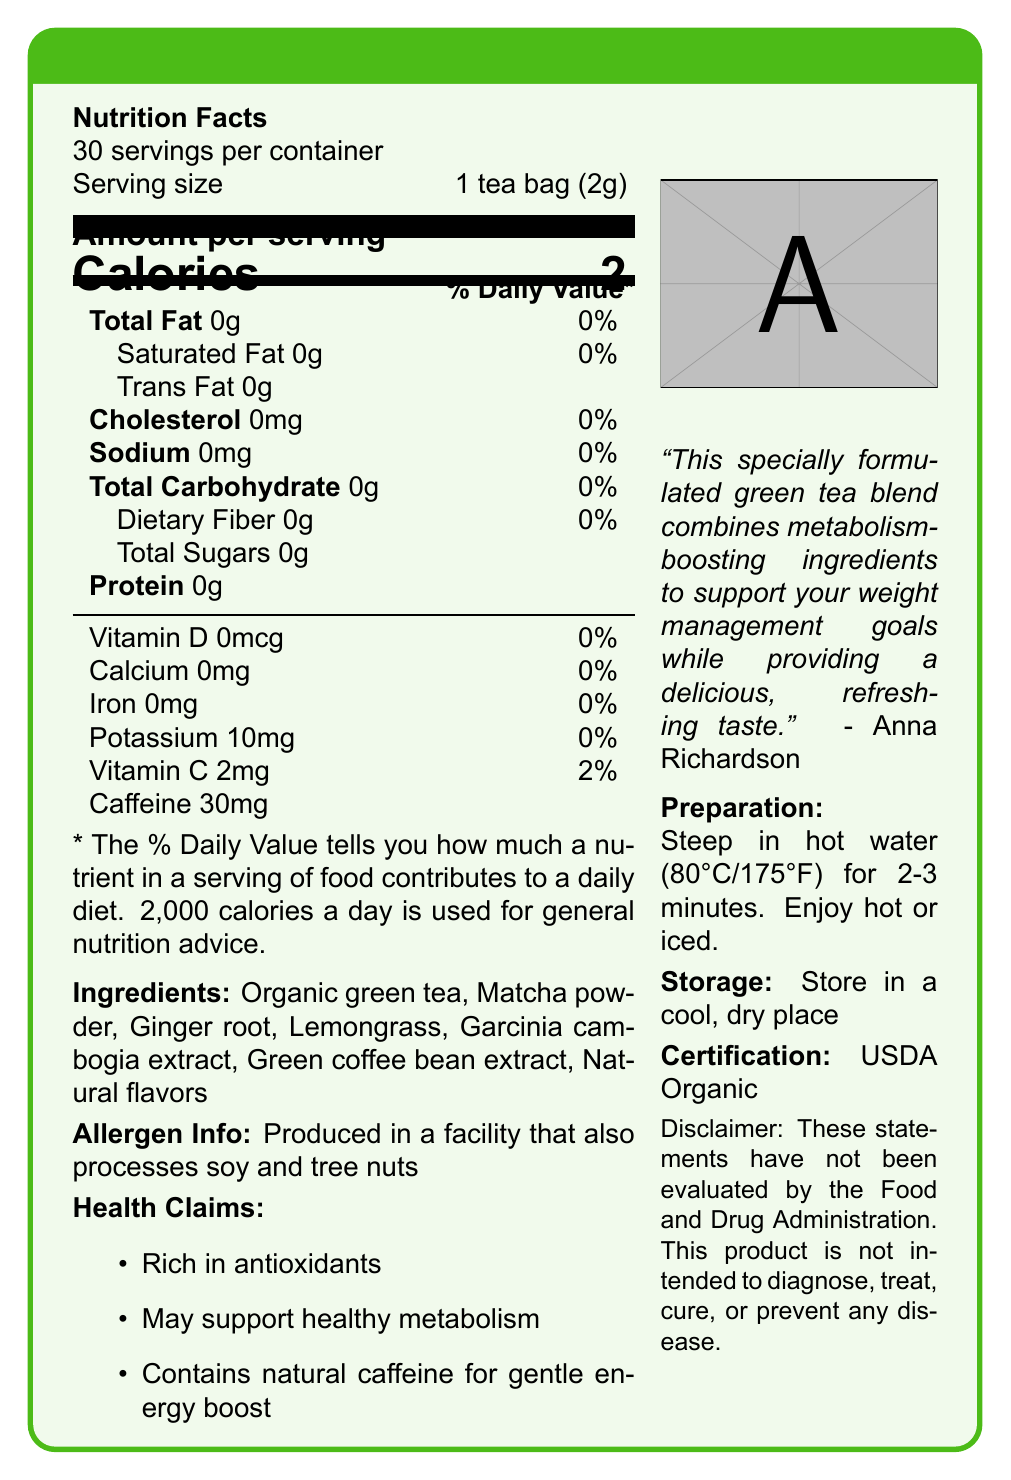what is the serving size? The serving size is clearly mentioned as "1 tea bag (2g)" in the document.
Answer: 1 tea bag (2g) how many calories are in one serving? The document lists the calories per serving as 2.
Answer: 2 what are the main ingredients in the tea blend? The main ingredients are listed under the "Ingredients" section.
Answer: Organic green tea, Matcha powder, Ginger root, Lemongrass, Garcinia cambogia extract, Green coffee bean extract, Natural flavors how many milligrams of caffeine does one serving contain? The caffeine content per serving is specified as 30 mg in the document.
Answer: 30 mg which vitamins are present in the tea blend? The document mentions Vitamin D (0 mcg) and Vitamin C (2 mg) in the nutrition facts.
Answer: Vitamin D, Vitamin C what are some of the health claims associated with the tea blend? A. Boosts energy B. Supports eye health C. Rich in antioxidants D. Supports healthy metabolism The health claims listed are "Rich in antioxidants" and "May support healthy metabolism".
Answer: C, D what allergen information is provided? The allergen information is clearly stated as "Produced in a facility that also processes soy and tree nuts".
Answer: Produced in a facility that also processes soy and tree nuts what is the certification status of the tea blend? A. Non-GMO B. USDA Organic C. Gluten-Free D. Fair Trade The document certifies the tea blend as "USDA Organic".
Answer: B what's the total carbohydrate content per serving? The total carbohydrate content per serving is listed as 0 grams.
Answer: 0 g are there any added sugars in the tea blend? The document lists total sugars as 0 grams, indicating no added sugars.
Answer: No is this tea caffeine-free? The tea blend contains 30 mg of caffeine per serving.
Answer: No where should the tea be stored? The storage instructions specify to store the tea in a cool, dry place.
Answer: In a cool, dry place what are the preparation instructions for the tea? The preparation instructions provided are "Steep in hot water (80°C/175°F) for 2-3 minutes. Enjoy hot or iced."
Answer: Steep in hot water (80°C/175°F) for 2-3 minutes. Enjoy hot or iced. what is the relationship between the product and Anna Richardson? Anna Richardson's quote is included in the document, endorsing the tea blend.
Answer: Anna Richardson endorses this tea blend with a quote. does the tea blend support weight management goals? The quote from Anna Richardson states that the tea blend supports weight management goals.
Answer: Yes what is the total fat content in the tea blend? The total fat content per serving is 0 grams as per the nutrition facts.
Answer: 0 g which specific ingredient is known for its metabolism-boosting properties? Green coffee bean extract is well-known for its metabolism-boosting properties.
Answer: Green coffee bean extract how many servings are in a container of the tea blend? The document specifies that there are 30 servings per container.
Answer: 30 what's the potassium content per serving? The document lists the potassium content as 10 mg per serving.
Answer: 10 mg can the effectiveness of the tea blend in diagnosing, treating, curing, or preventing any disease be confirmed based on the document? The disclaimer clearly states that the product is not intended to diagnose, treat, cure, or prevent any disease.
Answer: No, these statements have not been evaluated by the FDA. summarize the main idea of the document. The document focuses on presenting a comprehensive overview of the tea blend, highlighting its health benefits, composition, and endorsements.
Answer: The document provides detailed nutrition facts and other product information for "Anna's Metabolism Boost Green Tea Blend," including ingredients, health claims, allergen info, preparation and storage instructions, and a certification. The tea is endorsed by Anna Richardson, contains metabolism-boosting ingredients, and is USDA Organic certified. 